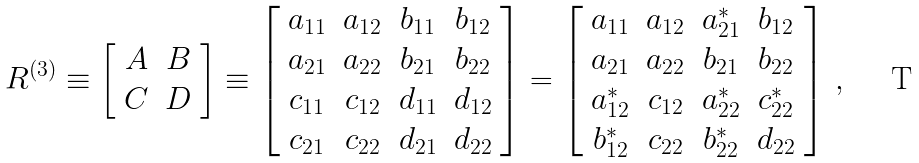<formula> <loc_0><loc_0><loc_500><loc_500>R ^ { ( 3 ) } \equiv \left [ \begin{array} { c c } A & B \\ C & D \end{array} \right ] \equiv \left [ \begin{array} { c c c c } a _ { 1 1 } & a _ { 1 2 } & b _ { 1 1 } & b _ { 1 2 } \\ a _ { 2 1 } & a _ { 2 2 } & b _ { 2 1 } & b _ { 2 2 } \\ c _ { 1 1 } & c _ { 1 2 } & d _ { 1 1 } & d _ { 1 2 } \\ c _ { 2 1 } & c _ { 2 2 } & d _ { 2 1 } & d _ { 2 2 } \end{array} \right ] = \left [ \begin{array} { c c c c } a _ { 1 1 } & a _ { 1 2 } & a _ { 2 1 } ^ { * } & b _ { 1 2 } \\ a _ { 2 1 } & a _ { 2 2 } & b _ { 2 1 } & b _ { 2 2 } \\ a _ { 1 2 } ^ { * } & c _ { 1 2 } & a _ { 2 2 } ^ { * } & c _ { 2 2 } ^ { * } \\ b _ { 1 2 } ^ { * } & c _ { 2 2 } & b _ { 2 2 } ^ { * } & d _ { 2 2 } \end{array} \right ] \, ,</formula> 